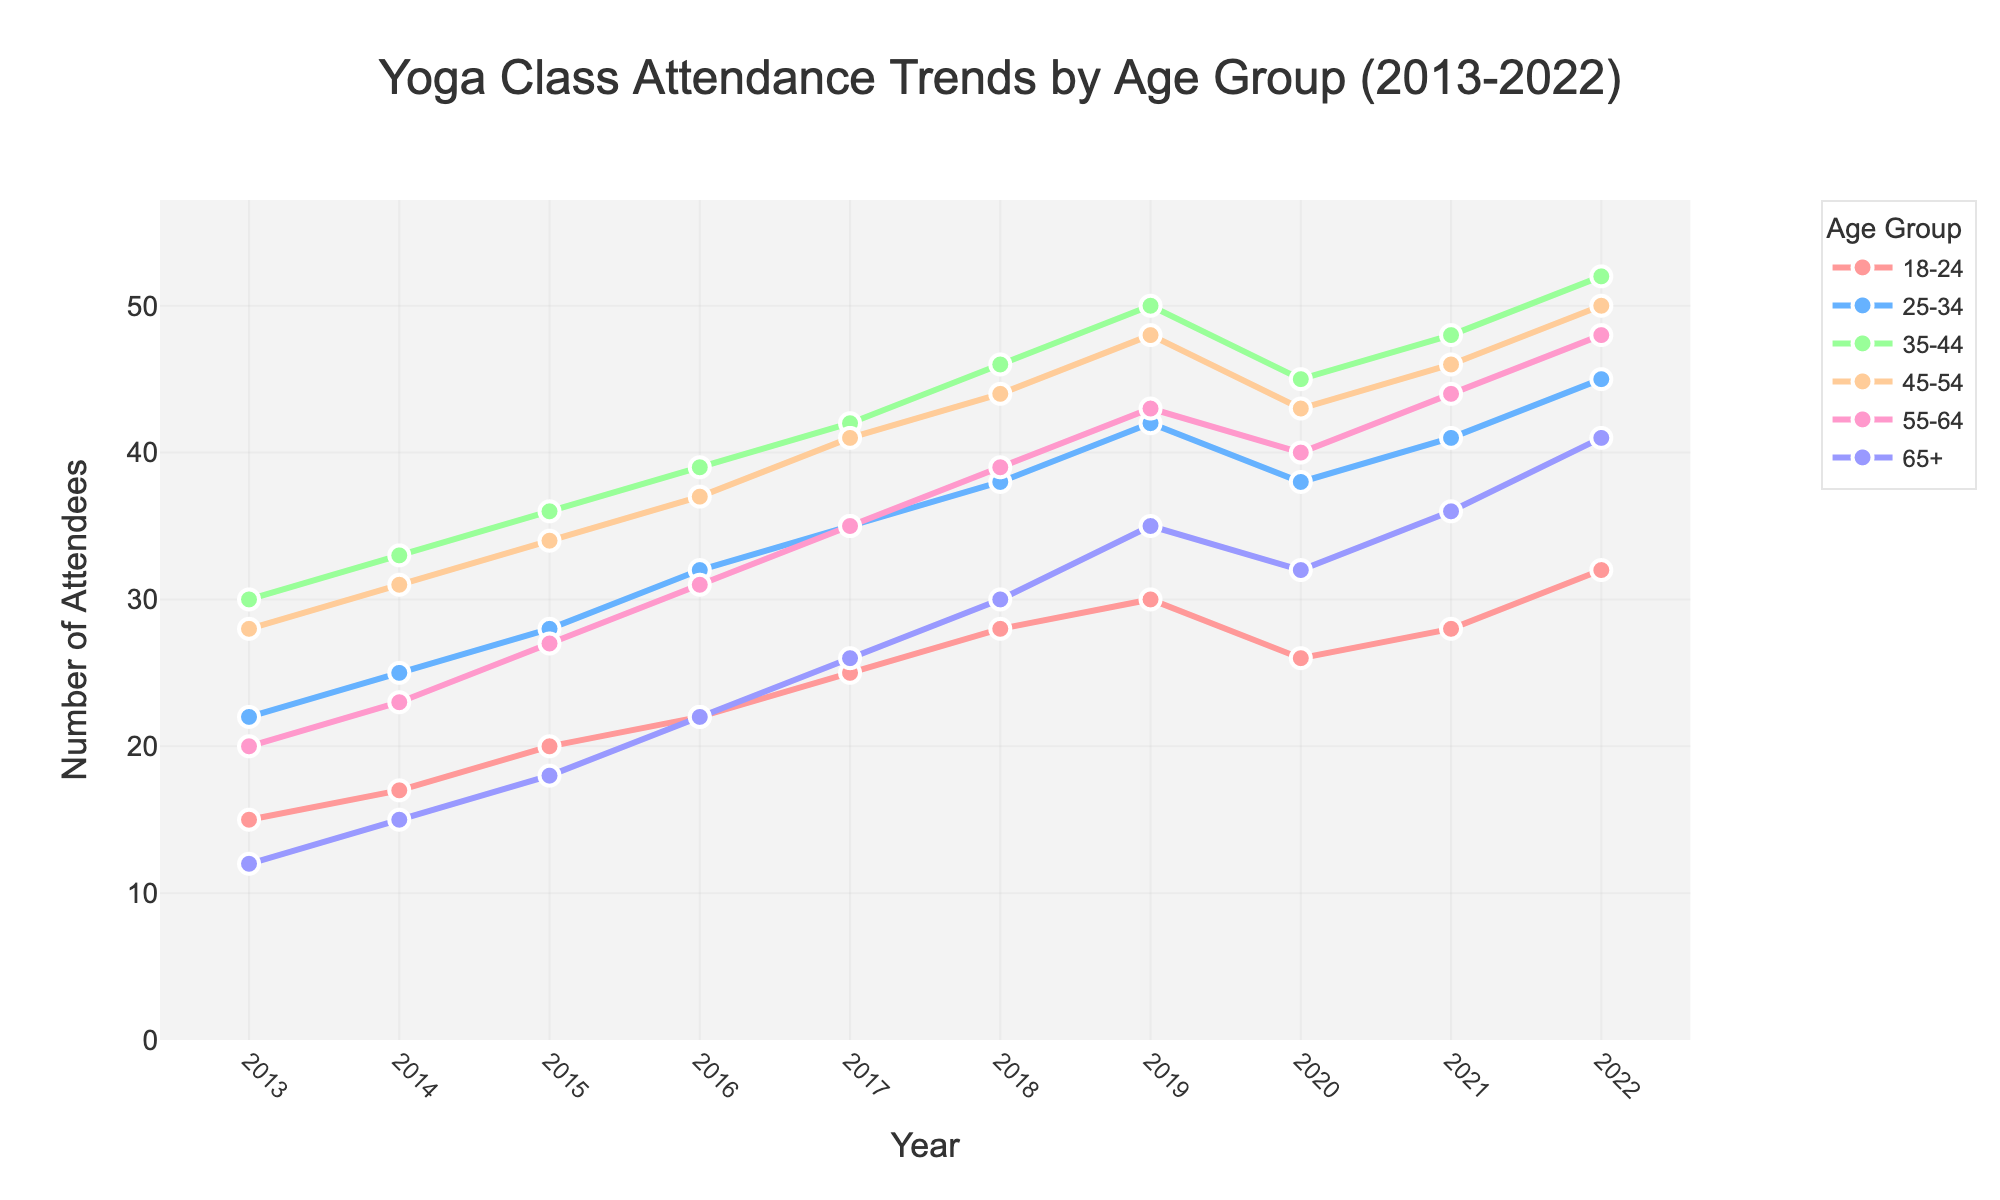What age group had the highest attendance in 2022? By looking at the end points of the lines corresponding to each age group in the year 2022, it's clear that the 35-44 age group has the highest number of attendees.
Answer: 35-44 How has the attendance trend for the 18-24 age group changed from 2013 to 2022? The attendance for the 18-24 age group has increased steadily from 15 attendees in 2013 to 32 attendees in 2022. This is a consistent upward trend.
Answer: Increased What is the difference in attendance between the 65+ and 55-64 age groups in 2022? In 2022, the 65+ age group has 41 attendees and the 55-64 age group has 48 attendees. The difference is 48 - 41 = 7 attendees.
Answer: 7 Which age group shows the most significant drop in attendance from 2019 to 2020? By comparing drops between 2019 and 2020 for each age group, we see the 35-44 age group had a drop from 50 to 45, which is the largest decrease of 5 attendees.
Answer: 35-44 What was the attendance trend for the 25-34 age group between 2018 and 2020? The 25-34 age group attendance increased from 38 in 2018 to 42 in 2019, then decreased to 38 in 2020. Thus, the trend is an increase followed by a decrease.
Answer: Increase followed by a decrease Among all age groups, which one had the lowest attendance in 2017? The data shows the 65+ age group had the lowest attendance in 2017 with 26 attendees.
Answer: 65+ Comparing the years 2015 and 2022, which age group had the greatest increase in attendance? The 65+ age group increased from 18 attendees in 2015 to 41 attendees in 2022. This is an increase of 41 - 18 = 23 attendees, which is the greatest increase among all age groups.
Answer: 65+ On average, how many attendees did the 45-54 age group have from 2013 to 2022? Summing the attendance numbers for the 45-54 age group from 2013 to 2022: (28 + 31 + 34 + 37 + 41 + 44 + 48 + 43 + 46 + 50) = 402. The average is 402 / 10 = 40.2 attendees.
Answer: 40.2 Which age group had no decline in attendance anytime from 2013 to 2022? By examining the trends, the 35-44 and 55-64 age groups show no decline in their attendance over the years.
Answer: 35-44 and 55-64 